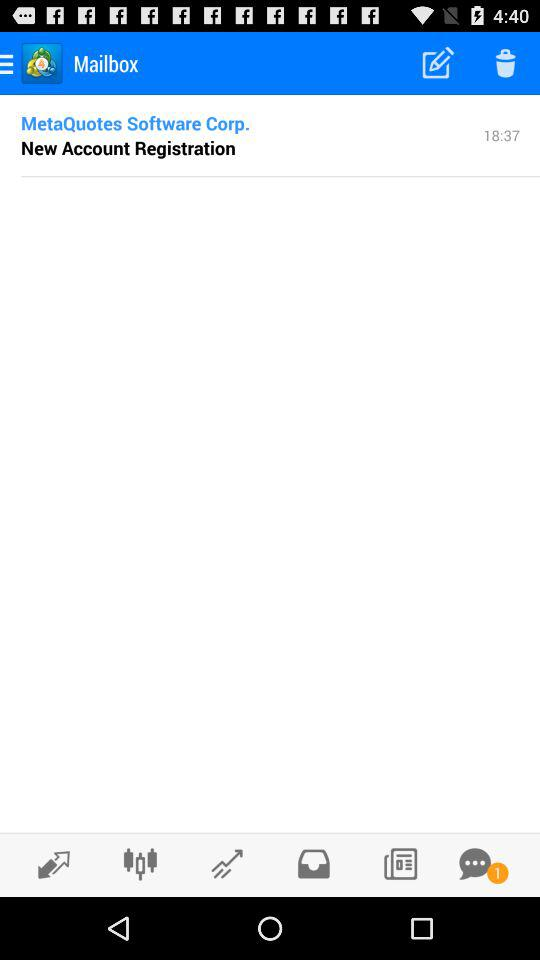How many pending notifications do I have in the chat option? There is 1 pending notification. 